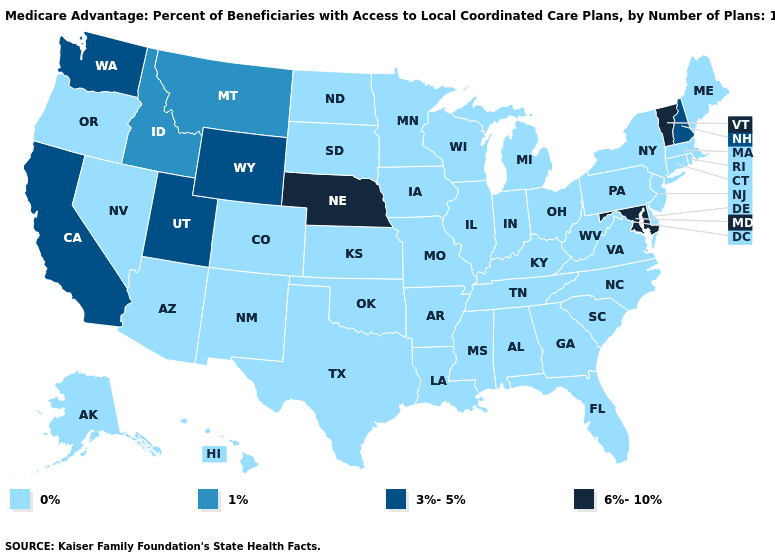What is the highest value in states that border Michigan?
Concise answer only. 0%. Does Wisconsin have the highest value in the MidWest?
Short answer required. No. Which states hav the highest value in the Northeast?
Concise answer only. Vermont. What is the highest value in the MidWest ?
Concise answer only. 6%-10%. Does Connecticut have the lowest value in the Northeast?
Short answer required. Yes. Does New Mexico have the highest value in the USA?
Answer briefly. No. Name the states that have a value in the range 1%?
Concise answer only. Idaho, Montana. Among the states that border Oklahoma , which have the highest value?
Be succinct. Colorado, Kansas, Missouri, New Mexico, Texas, Arkansas. Name the states that have a value in the range 1%?
Quick response, please. Idaho, Montana. Does Kentucky have the lowest value in the South?
Concise answer only. Yes. What is the value of Nebraska?
Short answer required. 6%-10%. Name the states that have a value in the range 6%-10%?
Answer briefly. Maryland, Nebraska, Vermont. Does Missouri have the lowest value in the USA?
Write a very short answer. Yes. Which states hav the highest value in the South?
Quick response, please. Maryland. 